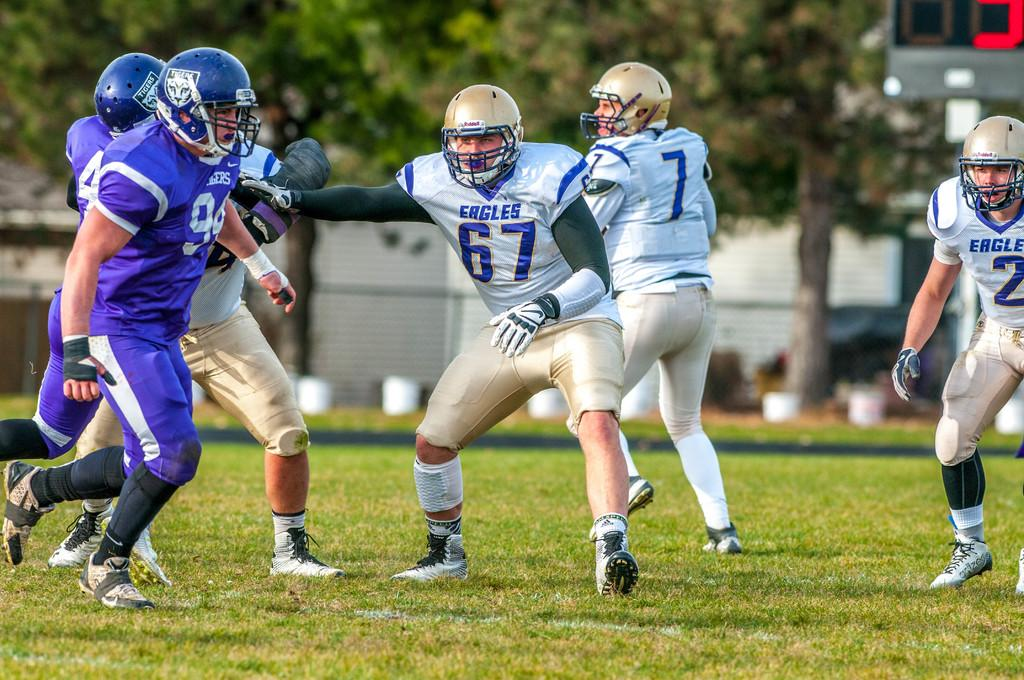What are the persons in the image doing? The persons visible on the ground are wearing helmets, which suggests they might be engaging in an activity that requires protective gear. What can be seen in the background of the image? There are trees, at least one building, a vehicle, and a wall visible in the background of the image. How many elements are present in the background of the image? There are four elements present in the background: trees, a building, a vehicle, and a wall. What type of station can be seen in the image? There is no station present in the image. What is the neck of the person doing in the image? The neck of the person is not doing anything in the image; it is simply part of the person's body. 